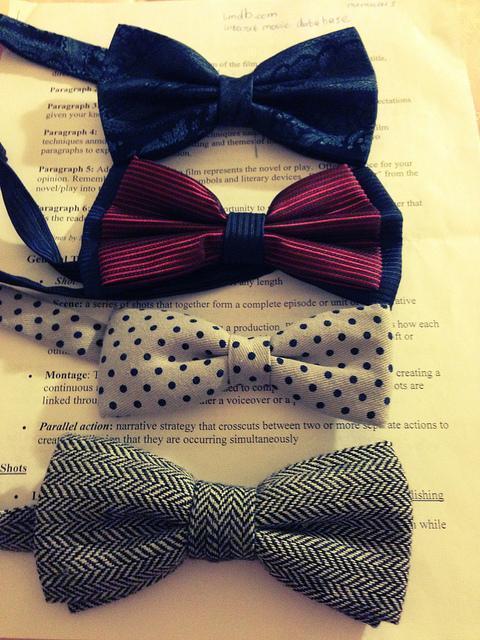How many bow ties are on the paper?
Give a very brief answer. 4. How many blue ties do you see?
Give a very brief answer. 1. How many ties are in the photo?
Give a very brief answer. 4. 